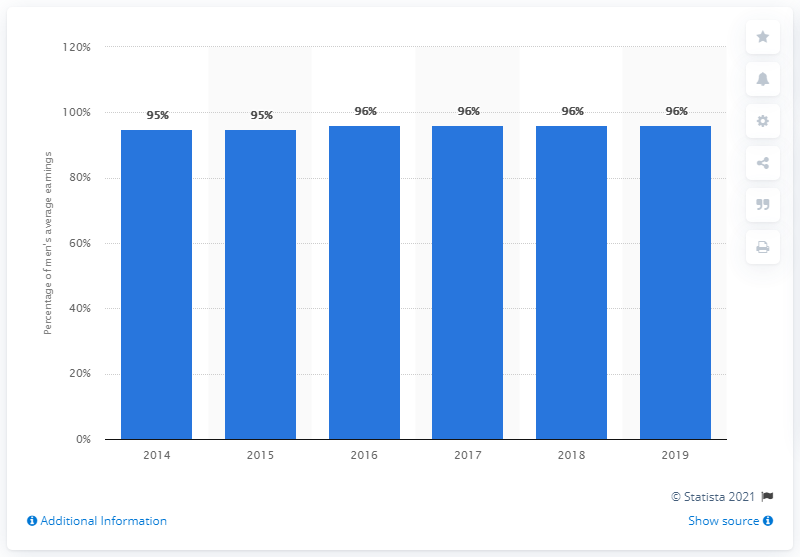Highlight a few significant elements in this photo. In 2019, women in Sweden earned 96% of the average earnings of men. 